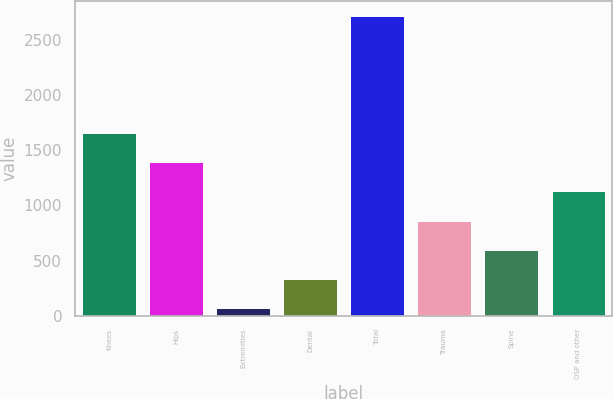Convert chart to OTSL. <chart><loc_0><loc_0><loc_500><loc_500><bar_chart><fcel>Knees<fcel>Hips<fcel>Extremities<fcel>Dental<fcel>Total<fcel>Trauma<fcel>Spine<fcel>OSP and other<nl><fcel>1659.04<fcel>1393.55<fcel>66.1<fcel>331.59<fcel>2721<fcel>862.57<fcel>597.08<fcel>1128.06<nl></chart> 